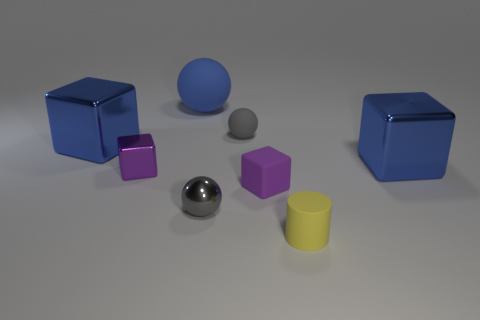Add 2 big yellow rubber cubes. How many objects exist? 10 Subtract all balls. How many objects are left? 5 Subtract 0 gray cylinders. How many objects are left? 8 Subtract all large purple shiny spheres. Subtract all gray rubber balls. How many objects are left? 7 Add 5 tiny cylinders. How many tiny cylinders are left? 6 Add 2 gray things. How many gray things exist? 4 